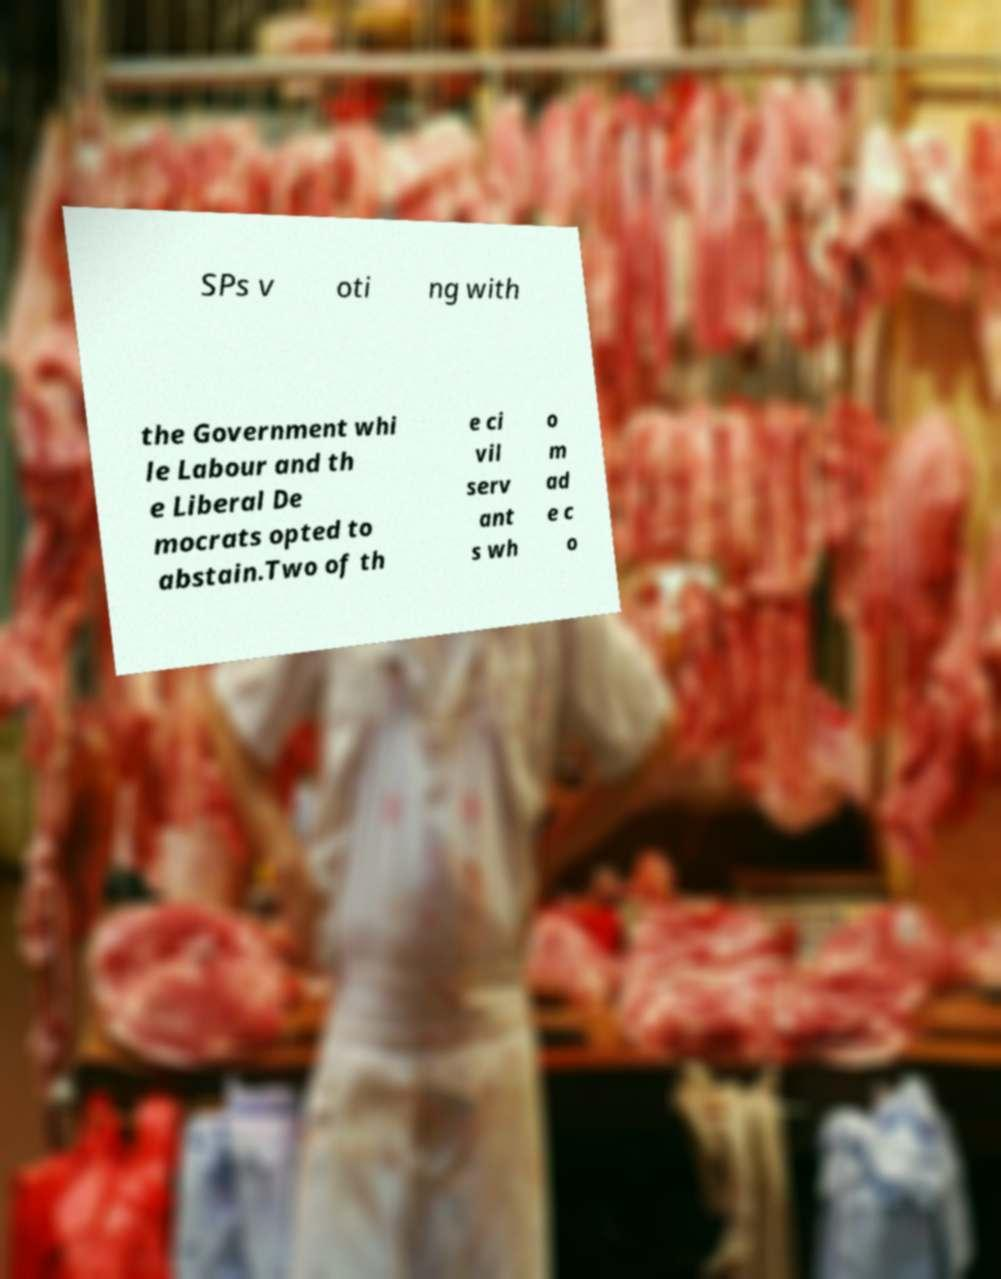There's text embedded in this image that I need extracted. Can you transcribe it verbatim? SPs v oti ng with the Government whi le Labour and th e Liberal De mocrats opted to abstain.Two of th e ci vil serv ant s wh o m ad e c o 